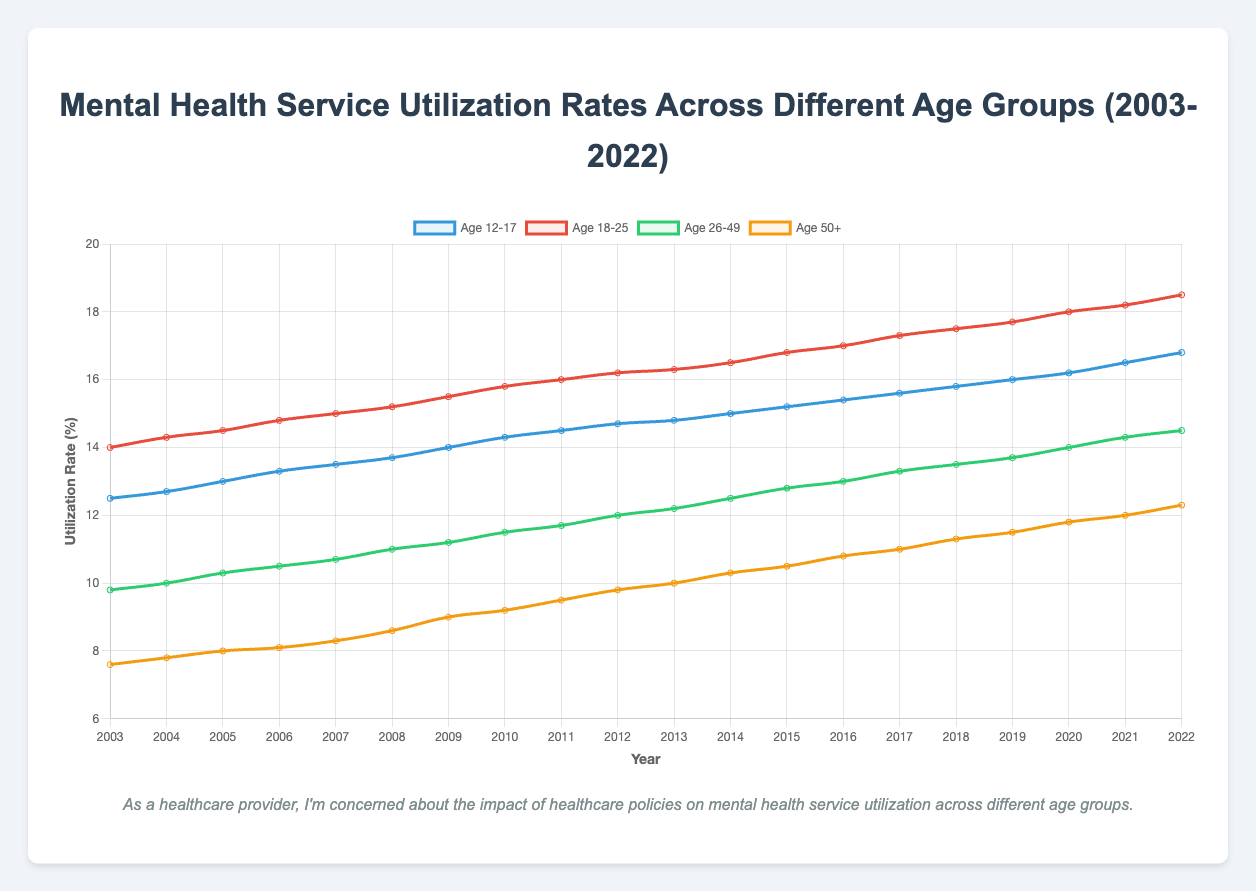What is the trend in mental health service utilization rates for the age group 12-17 between 2003 and 2022? The utilization rates for the age group 12-17 have been steadily increasing from 12.5% in 2003 to 16.8% in 2022. This indicates a gradual rise in the percentage of individuals in this age group using mental health services over the given period.
Answer: Increasing Which age group had the highest utilization rate in 2022, and what was the rate? In 2022, the age group 18-25 had the highest mental health service utilization rate at 18.5%. This can be seen in the figure as the line representing this age group reaches the highest point compared to other age groups in 2022.
Answer: 18-25, 18.5% How did the mental health service utilization rate for age group 50+ change from 2003 to 2022? The utilization rate for the age group 50+ increased from 7.6% in 2003 to 12.3% in 2022. This is an increase of 4.7 percentage points over the 20-year span.
Answer: Increased by 4.7% What is the difference in utilization rates between the age groups 18-25 and 50+ in 2020? In 2020, the utilization rate for the age group 18-25 is 18.0%, while for the age group 50+ it is 11.8%. The difference is 18.0% - 11.8% = 6.2%.
Answer: 6.2% Compare the rate of change in mental health service utilization between the age groups 12-17 and 26-49 from 2015 to 2021. For the age group 12-17, the utilization rate increased from 15.2% in 2015 to 16.5% in 2021, a change of 1.3 percentage points. For the age group 26-49, the rate increased from 12.8% in 2015 to 14.3% in 2021, a change of 1.5 percentage points.
Answer: 12-17: 1.3%, 26-49: 1.5% What was the overall trend for the age group 26-49 from 2003 to 2022? The utilization rate for the age group 26-49 increased from 9.8% in 2003 to 14.5% in 2022. This shows an overall upward trend in mental health service utilization for this age group over the 20-year period.
Answer: Increasing Which age group had the smallest utilization rate in 2003, and how did it compare to their rate in 2022? In 2003, the age group 50+ had the smallest utilization rate at 7.6%. By 2022, this rate had increased to 12.3%. This is an increase of 4.7%.
Answer: 50+, 4.7% What was the average utilization rate for the age group 18-25 over the entire period from 2003 to 2022? The sum of the utilization rates for the age group 18-25 from 2003 to 2022 is 299.2%. There are 20 years in this period. So, the average rate = 299.2% / 20 = 14.96%.
Answer: 14.96% Has the gap between the utilization rates of age group 12-17 and 50+ widened or narrowed from 2003 to 2022? In 2003, the gap between the age group 12-17 (12.5%) and age group 50+ (7.6%) was 12.5% - 7.6% = 4.9%. In 2022, the gap was 16.8% - 12.3% = 4.5%. The gap has slightly narrowed by 0.4%.
Answer: Narrowed by 0.4% 